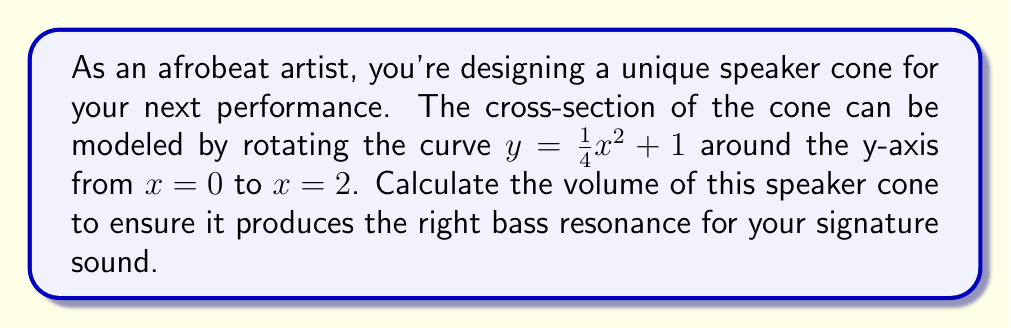What is the answer to this math problem? To find the volume of the speaker cone, we need to use the method of cylindrical shells. The steps are as follows:

1) The general formula for the volume of a solid formed by rotating a curve around the y-axis is:

   $$V = 2\pi \int_a^b x f(x) dx$$

   where $f(x)$ is the function being rotated, and $[a,b]$ is the interval.

2) In this case, $f(x) = \frac{1}{4}x^2 + 1$, $a = 0$, and $b = 2$.

3) Substituting these into our formula:

   $$V = 2\pi \int_0^2 x (\frac{1}{4}x^2 + 1) dx$$

4) Expand the integrand:

   $$V = 2\pi \int_0^2 (\frac{1}{4}x^3 + x) dx$$

5) Integrate:

   $$V = 2\pi [\frac{1}{16}x^4 + \frac{1}{2}x^2]_0^2$$

6) Evaluate the integral:

   $$V = 2\pi [(\frac{1}{16}(2^4) + \frac{1}{2}(2^2)) - (\frac{1}{16}(0^4) + \frac{1}{2}(0^2))]$$

   $$V = 2\pi [\frac{16}{16} + 2 - 0]$$

   $$V = 2\pi [3]$$

7) Simplify:

   $$V = 6\pi$$

Therefore, the volume of the speaker cone is $6\pi$ cubic units.
Answer: $6\pi$ cubic units 